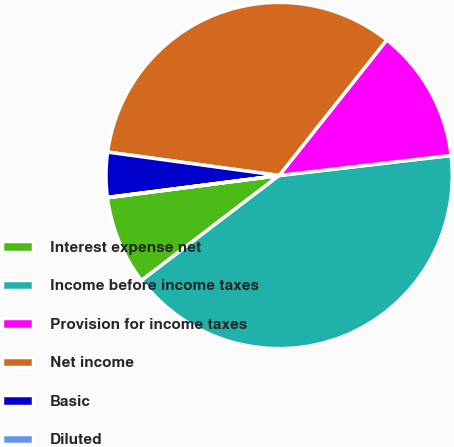Convert chart. <chart><loc_0><loc_0><loc_500><loc_500><pie_chart><fcel>Interest expense net<fcel>Income before income taxes<fcel>Provision for income taxes<fcel>Net income<fcel>Basic<fcel>Diluted<nl><fcel>8.32%<fcel>41.48%<fcel>12.47%<fcel>33.52%<fcel>4.18%<fcel>0.03%<nl></chart> 